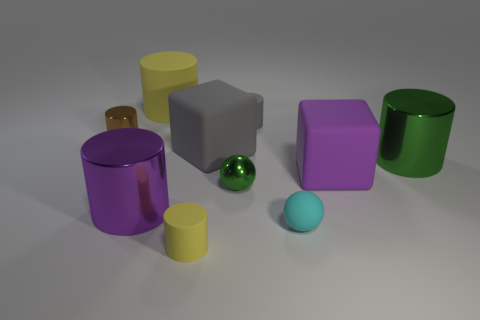There is a small matte cylinder that is on the right side of the small yellow cylinder; does it have the same color as the tiny metal object behind the gray cube? No, the small matte cylinder to the right of the small yellow cylinder does not have the same color as the tiny metal object. The cylinder appears to be purple, while the metal object is green and has a reflective surface. 